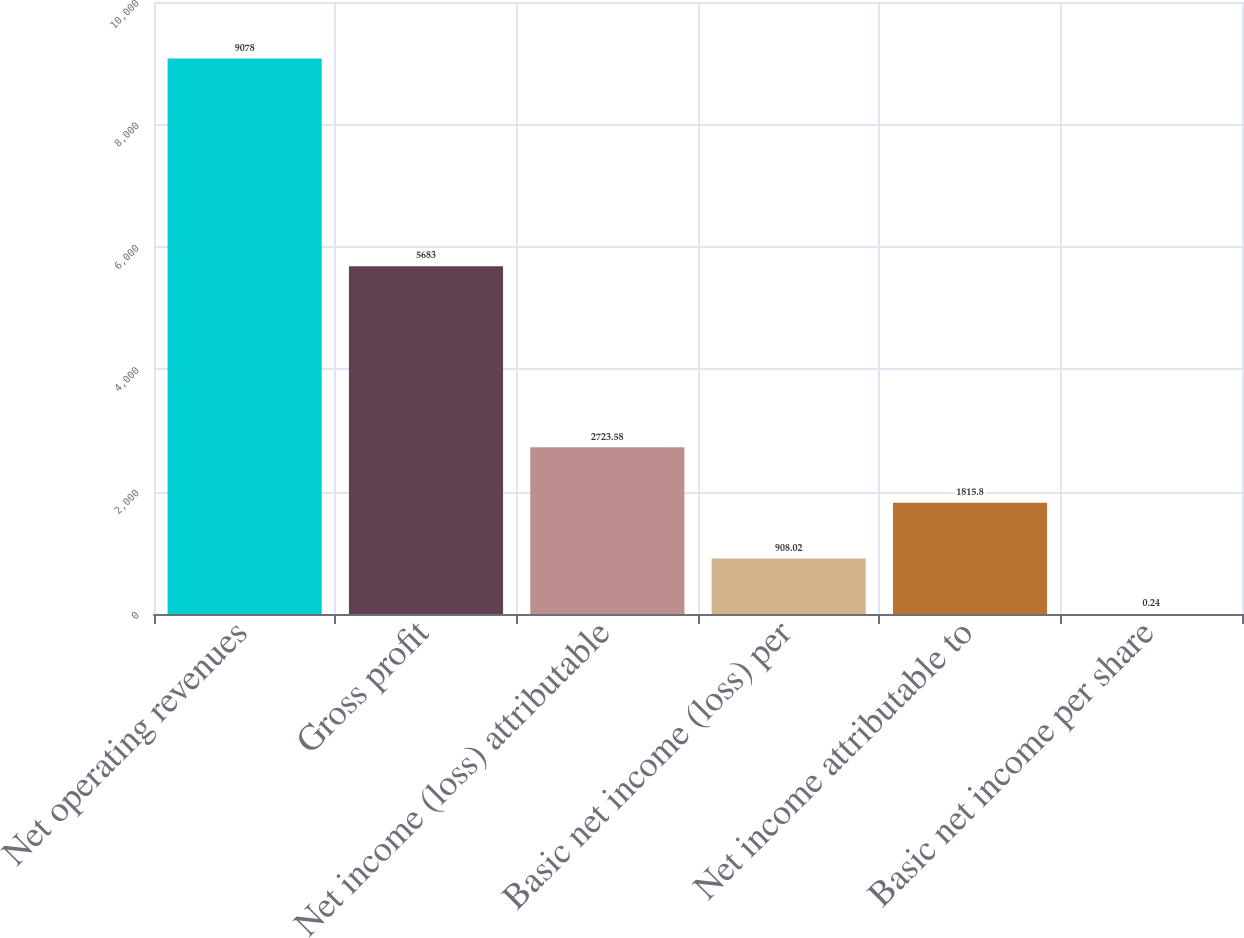Convert chart. <chart><loc_0><loc_0><loc_500><loc_500><bar_chart><fcel>Net operating revenues<fcel>Gross profit<fcel>Net income (loss) attributable<fcel>Basic net income (loss) per<fcel>Net income attributable to<fcel>Basic net income per share<nl><fcel>9078<fcel>5683<fcel>2723.58<fcel>908.02<fcel>1815.8<fcel>0.24<nl></chart> 